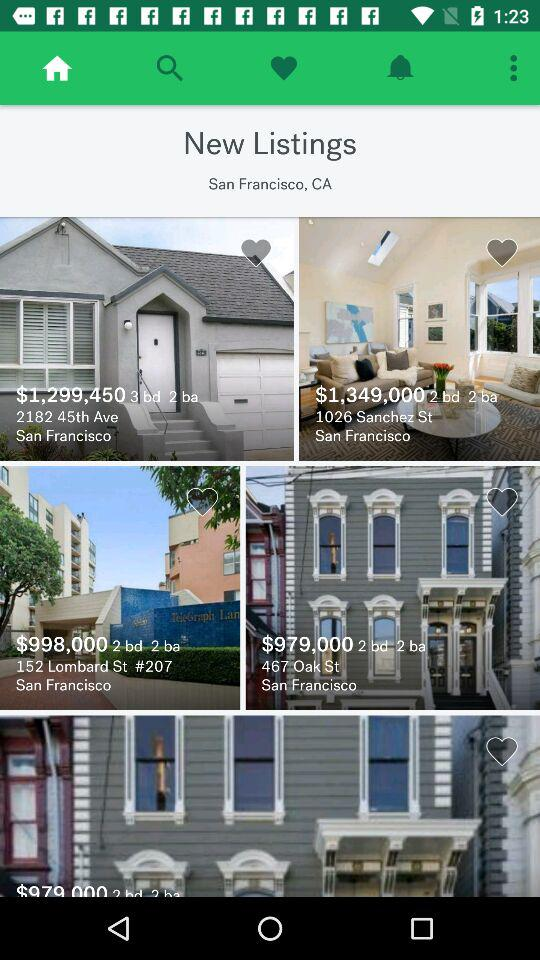What is the address of the house whose price is $998,000? The address is 152 Lombard St, # 207, San Francisco. 